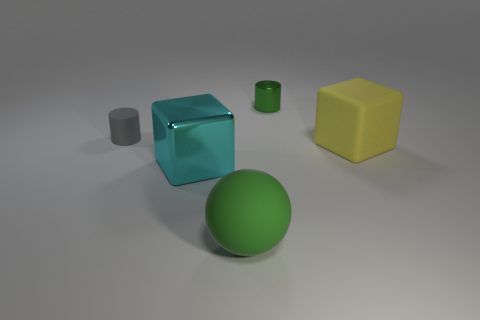Are there any metallic objects in front of the tiny cylinder that is left of the green cylinder?
Your response must be concise. Yes. What number of other things are the same shape as the green metal object?
Give a very brief answer. 1. Do the small gray thing and the green metallic thing have the same shape?
Your answer should be very brief. Yes. What is the color of the thing that is behind the metallic cube and in front of the gray rubber thing?
Your response must be concise. Yellow. The shiny cylinder that is the same color as the sphere is what size?
Provide a succinct answer. Small. What number of small objects are cyan rubber cylinders or gray cylinders?
Make the answer very short. 1. Are there any other things of the same color as the sphere?
Provide a short and direct response. Yes. There is a cylinder that is on the left side of the metallic thing that is on the left side of the matte thing that is in front of the metal cube; what is its material?
Your answer should be compact. Rubber. What number of rubber objects are either large yellow blocks or blue blocks?
Provide a short and direct response. 1. How many red things are either metal cylinders or large objects?
Ensure brevity in your answer.  0. 